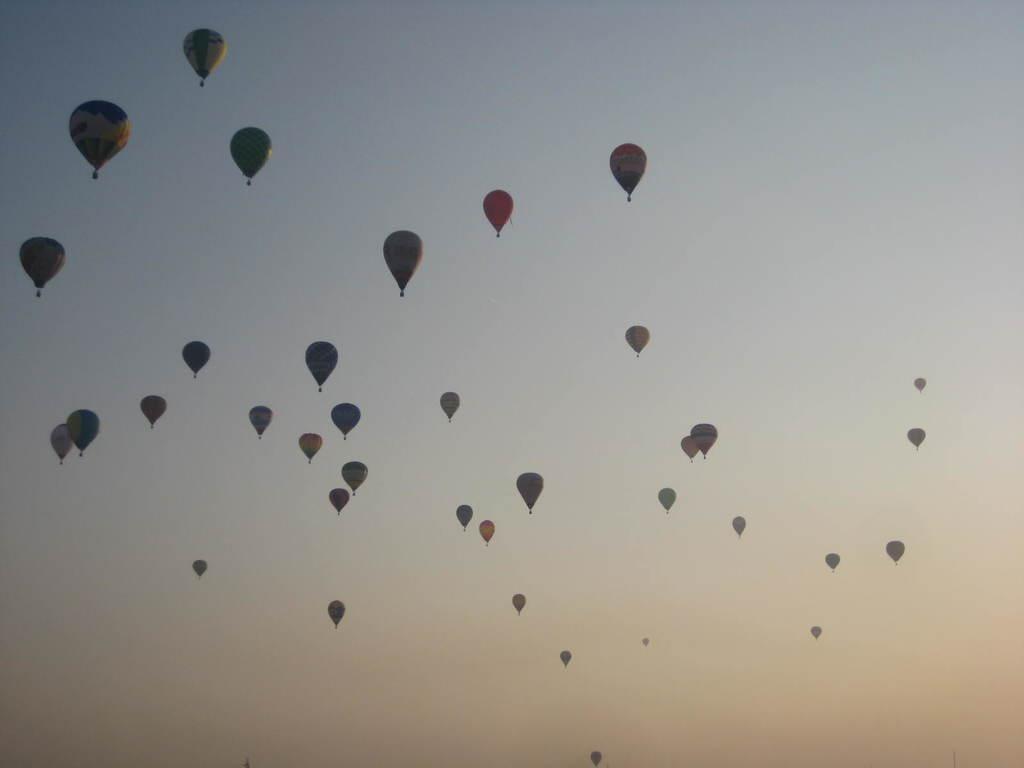In one or two sentences, can you explain what this image depicts? In this picture we can see some hot air balloon in the air, in the background there is the sky. 